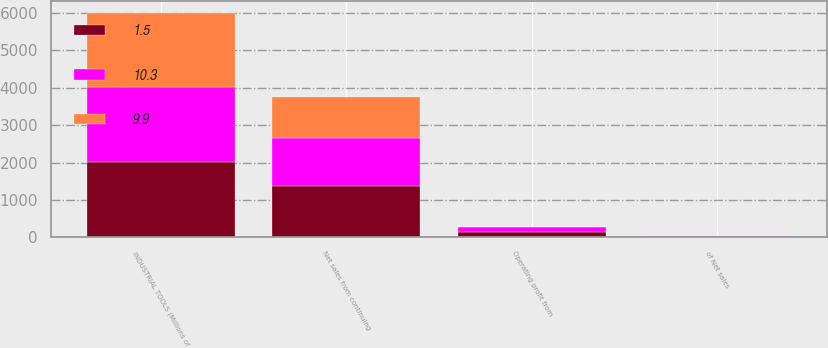Convert chart. <chart><loc_0><loc_0><loc_500><loc_500><stacked_bar_chart><ecel><fcel>INDUSTRIAL TOOLS (Millions of<fcel>Net sales from continuing<fcel>Operating profit from<fcel>of Net sales<nl><fcel>1.5<fcel>2005<fcel>1370<fcel>136<fcel>9.9<nl><fcel>10.3<fcel>2004<fcel>1293<fcel>133<fcel>10.3<nl><fcel>9.9<fcel>2003<fcel>1098<fcel>17<fcel>1.5<nl></chart> 